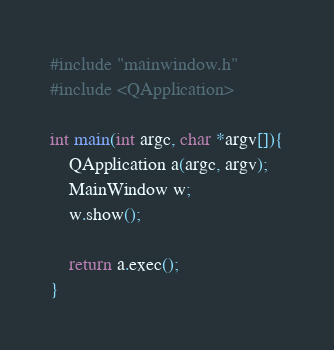<code> <loc_0><loc_0><loc_500><loc_500><_C++_>#include "mainwindow.h"
#include <QApplication>

int main(int argc, char *argv[]){
    QApplication a(argc, argv);
    MainWindow w;
    w.show();

    return a.exec();
}
</code> 